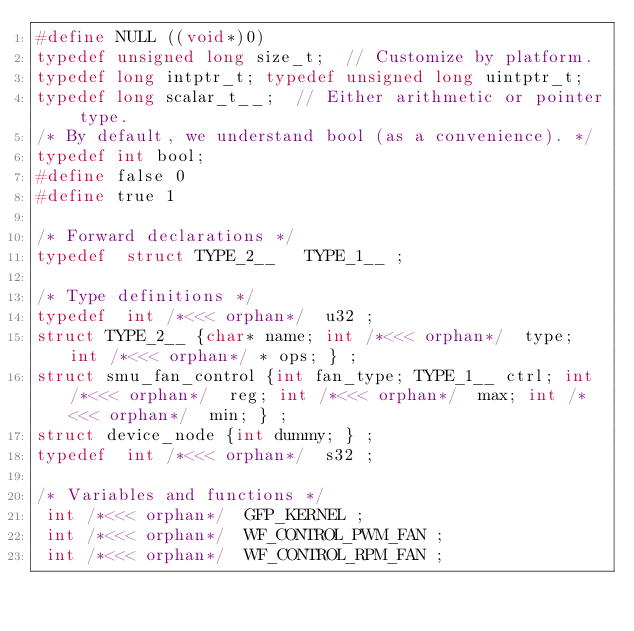Convert code to text. <code><loc_0><loc_0><loc_500><loc_500><_C_>#define NULL ((void*)0)
typedef unsigned long size_t;  // Customize by platform.
typedef long intptr_t; typedef unsigned long uintptr_t;
typedef long scalar_t__;  // Either arithmetic or pointer type.
/* By default, we understand bool (as a convenience). */
typedef int bool;
#define false 0
#define true 1

/* Forward declarations */
typedef  struct TYPE_2__   TYPE_1__ ;

/* Type definitions */
typedef  int /*<<< orphan*/  u32 ;
struct TYPE_2__ {char* name; int /*<<< orphan*/  type; int /*<<< orphan*/ * ops; } ;
struct smu_fan_control {int fan_type; TYPE_1__ ctrl; int /*<<< orphan*/  reg; int /*<<< orphan*/  max; int /*<<< orphan*/  min; } ;
struct device_node {int dummy; } ;
typedef  int /*<<< orphan*/  s32 ;

/* Variables and functions */
 int /*<<< orphan*/  GFP_KERNEL ; 
 int /*<<< orphan*/  WF_CONTROL_PWM_FAN ; 
 int /*<<< orphan*/  WF_CONTROL_RPM_FAN ; </code> 